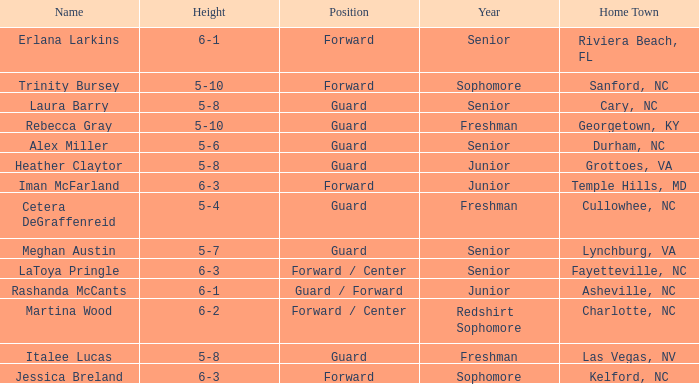What's the stature of the freshman guard cetera degraffenreid? 5-4. 